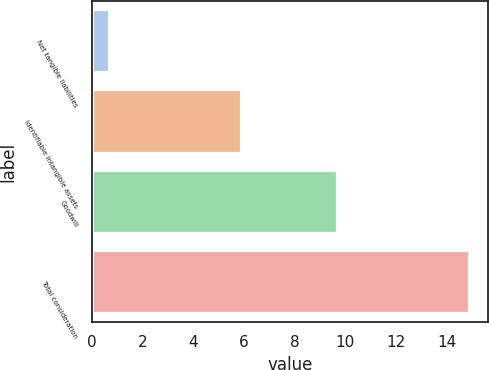Convert chart to OTSL. <chart><loc_0><loc_0><loc_500><loc_500><bar_chart><fcel>Net tangible liabilities<fcel>Identifiable intangible assets<fcel>Goodwill<fcel>Total consideration<nl><fcel>0.7<fcel>5.9<fcel>9.7<fcel>14.9<nl></chart> 